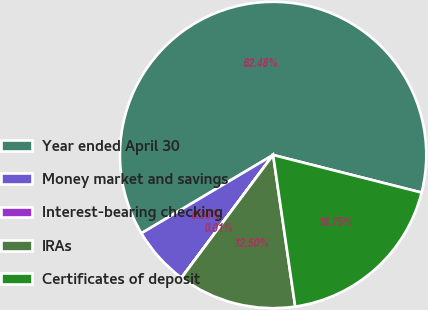Convert chart. <chart><loc_0><loc_0><loc_500><loc_500><pie_chart><fcel>Year ended April 30<fcel>Money market and savings<fcel>Interest-bearing checking<fcel>IRAs<fcel>Certificates of deposit<nl><fcel>62.48%<fcel>6.26%<fcel>0.01%<fcel>12.5%<fcel>18.75%<nl></chart> 